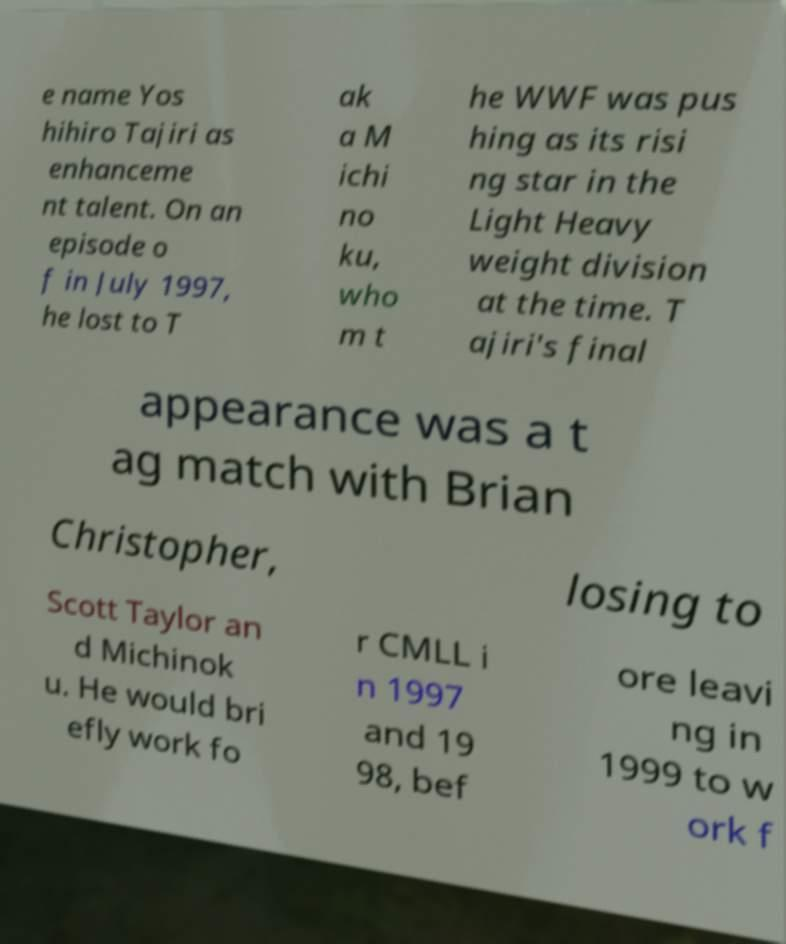There's text embedded in this image that I need extracted. Can you transcribe it verbatim? e name Yos hihiro Tajiri as enhanceme nt talent. On an episode o f in July 1997, he lost to T ak a M ichi no ku, who m t he WWF was pus hing as its risi ng star in the Light Heavy weight division at the time. T ajiri's final appearance was a t ag match with Brian Christopher, losing to Scott Taylor an d Michinok u. He would bri efly work fo r CMLL i n 1997 and 19 98, bef ore leavi ng in 1999 to w ork f 